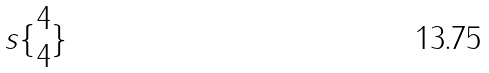<formula> <loc_0><loc_0><loc_500><loc_500>s \{ \begin{matrix} 4 \\ 4 \end{matrix} \}</formula> 